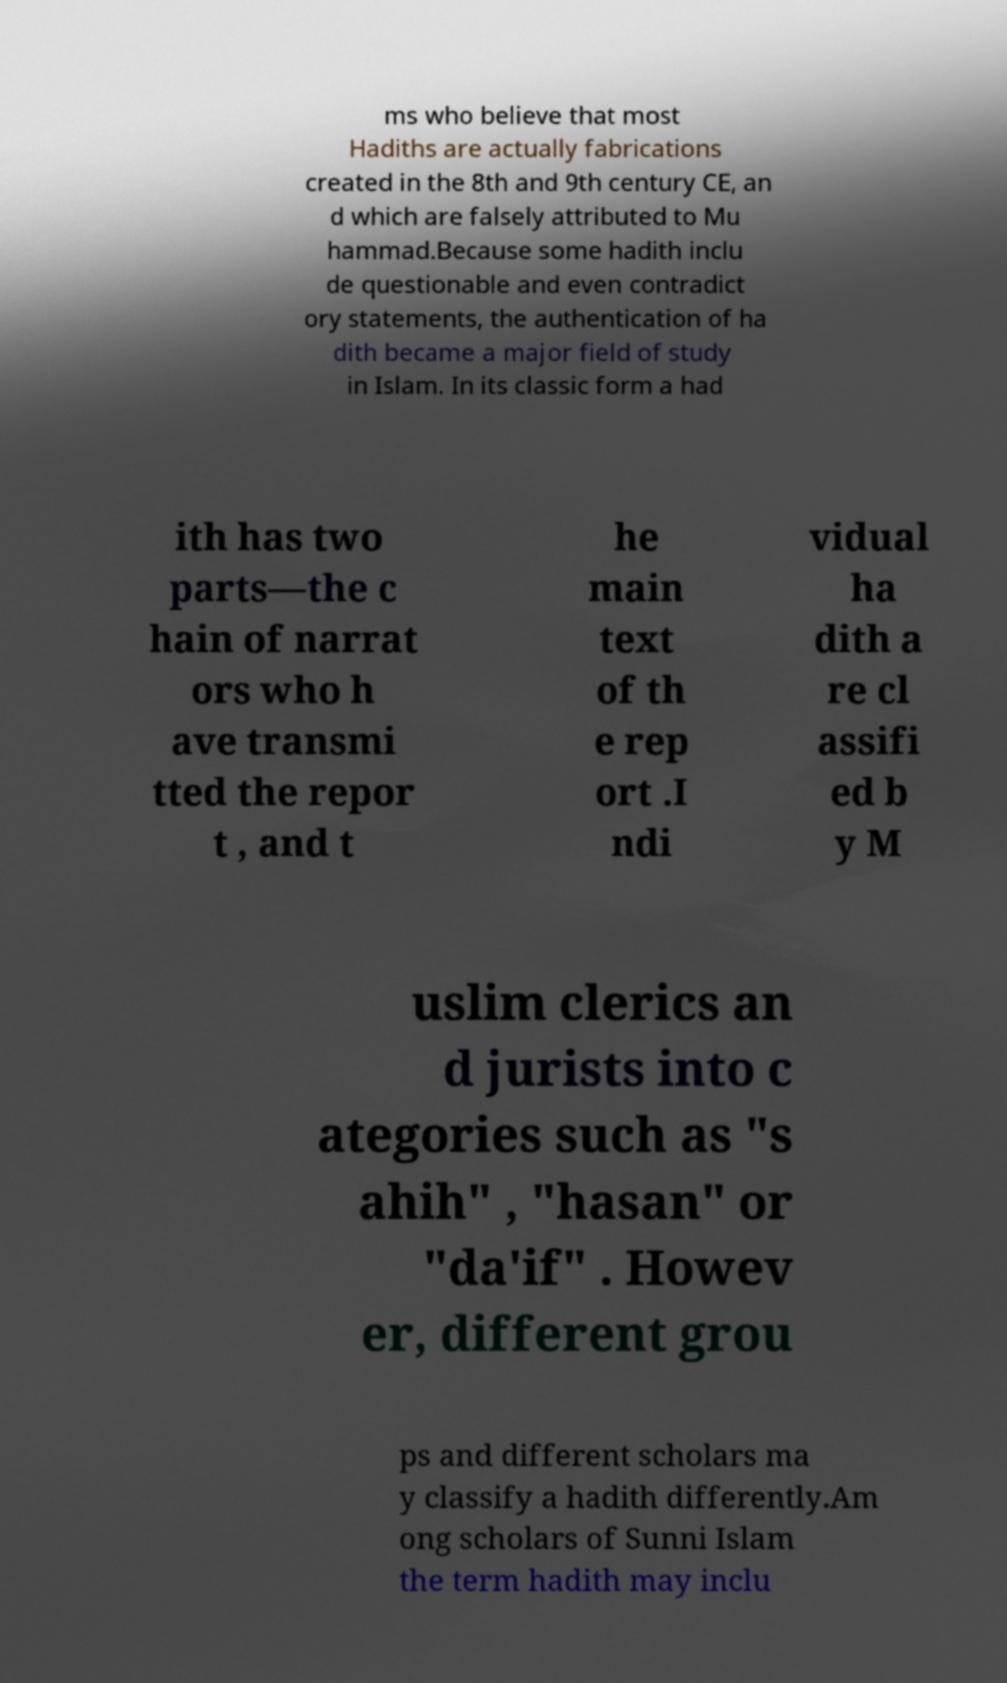For documentation purposes, I need the text within this image transcribed. Could you provide that? ms who believe that most Hadiths are actually fabrications created in the 8th and 9th century CE, an d which are falsely attributed to Mu hammad.Because some hadith inclu de questionable and even contradict ory statements, the authentication of ha dith became a major field of study in Islam. In its classic form a had ith has two parts—the c hain of narrat ors who h ave transmi tted the repor t , and t he main text of th e rep ort .I ndi vidual ha dith a re cl assifi ed b y M uslim clerics an d jurists into c ategories such as "s ahih" , "hasan" or "da'if" . Howev er, different grou ps and different scholars ma y classify a hadith differently.Am ong scholars of Sunni Islam the term hadith may inclu 